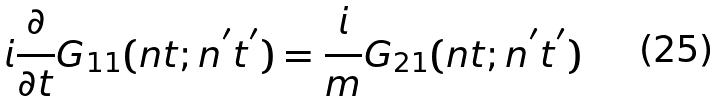Convert formula to latex. <formula><loc_0><loc_0><loc_500><loc_500>i \frac { \partial } { \partial t } G _ { 1 1 } ( n t ; n ^ { ^ { \prime } } t ^ { ^ { \prime } } ) = \frac { i } { m } G _ { 2 1 } ( n t ; n ^ { ^ { \prime } } t ^ { ^ { \prime } } )</formula> 